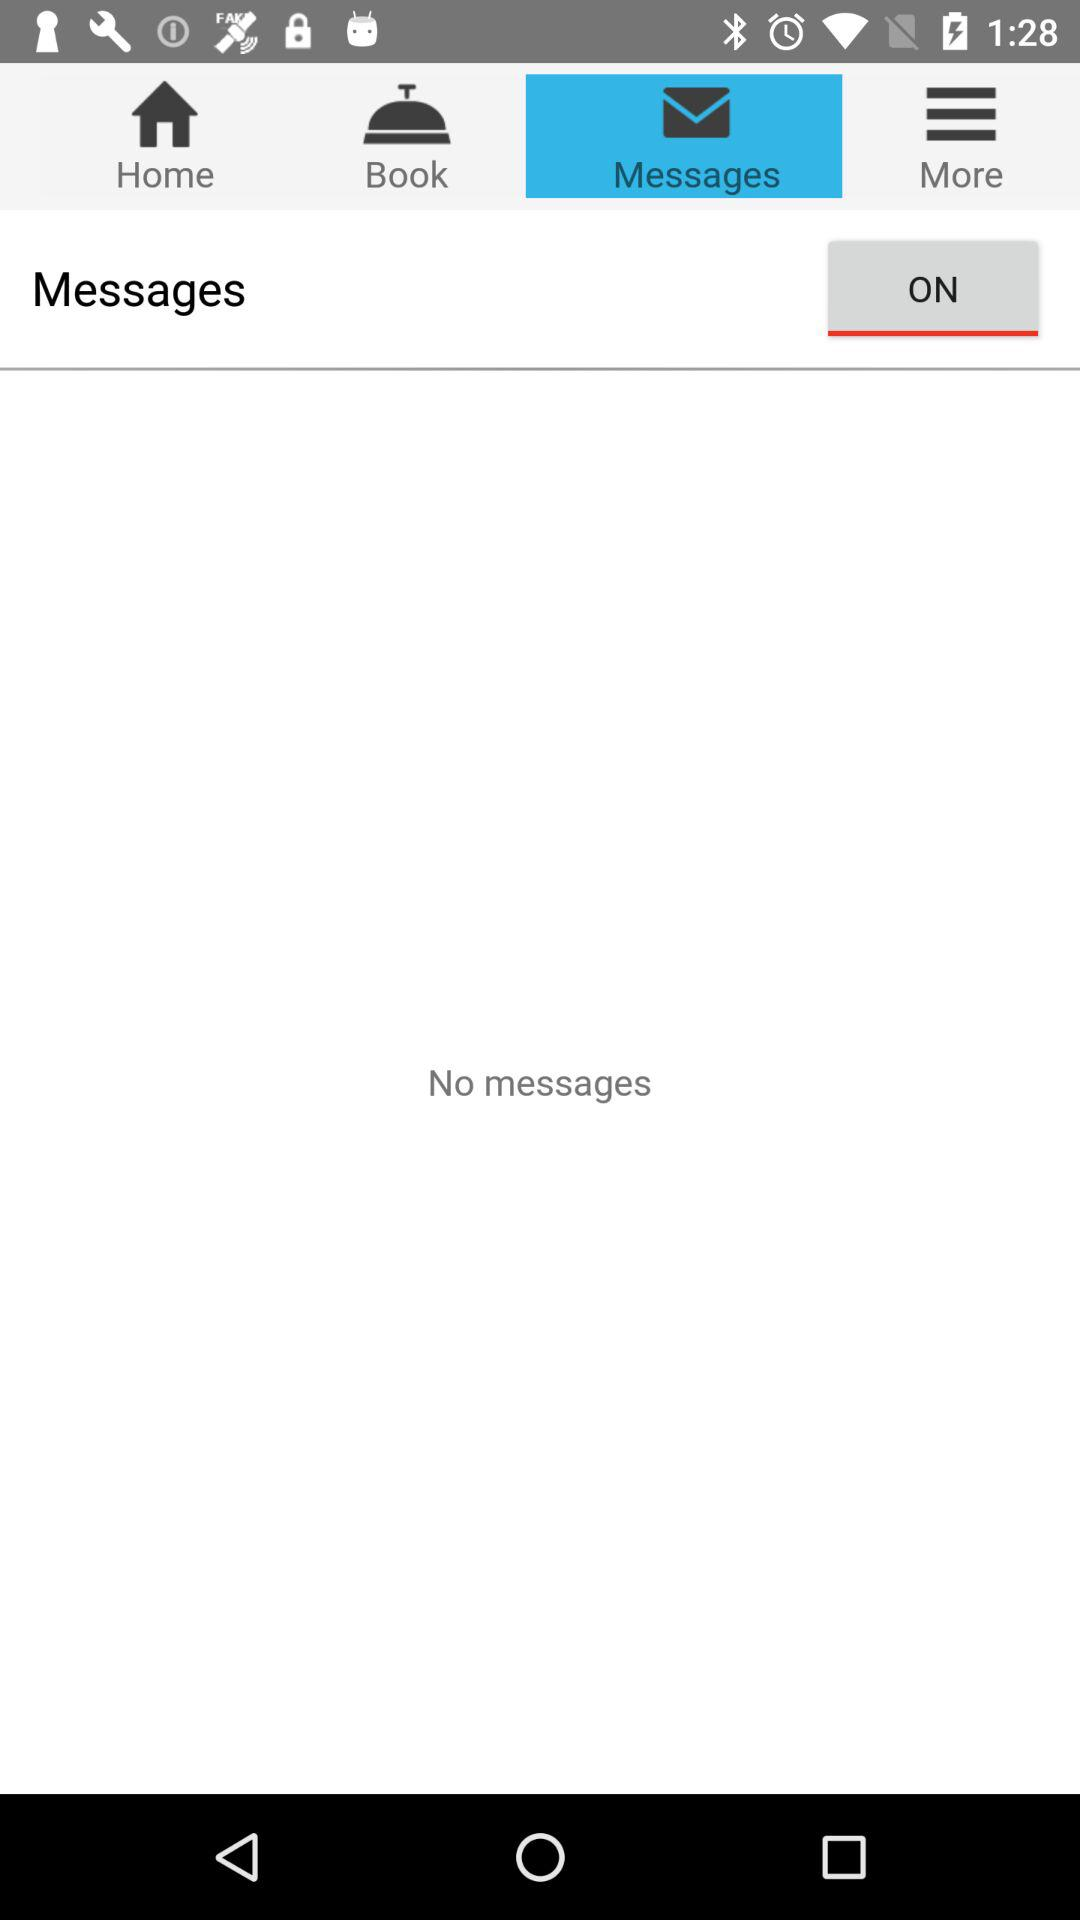Which tab is selected? The selected tab is "Messages". 